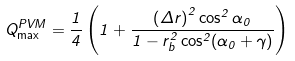Convert formula to latex. <formula><loc_0><loc_0><loc_500><loc_500>Q _ { \max } ^ { P V M } = \frac { 1 } { 4 } \left ( 1 + \frac { \left ( \Delta r \right ) ^ { 2 } \cos ^ { 2 } \alpha _ { 0 } } { 1 - r _ { b } ^ { 2 } \cos ^ { 2 } ( \alpha _ { 0 } + \gamma ) } \right ) \,</formula> 